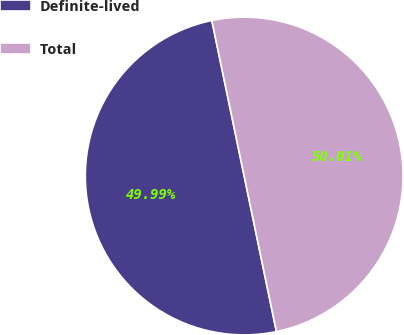<chart> <loc_0><loc_0><loc_500><loc_500><pie_chart><fcel>Definite-lived<fcel>Total<nl><fcel>49.99%<fcel>50.01%<nl></chart> 